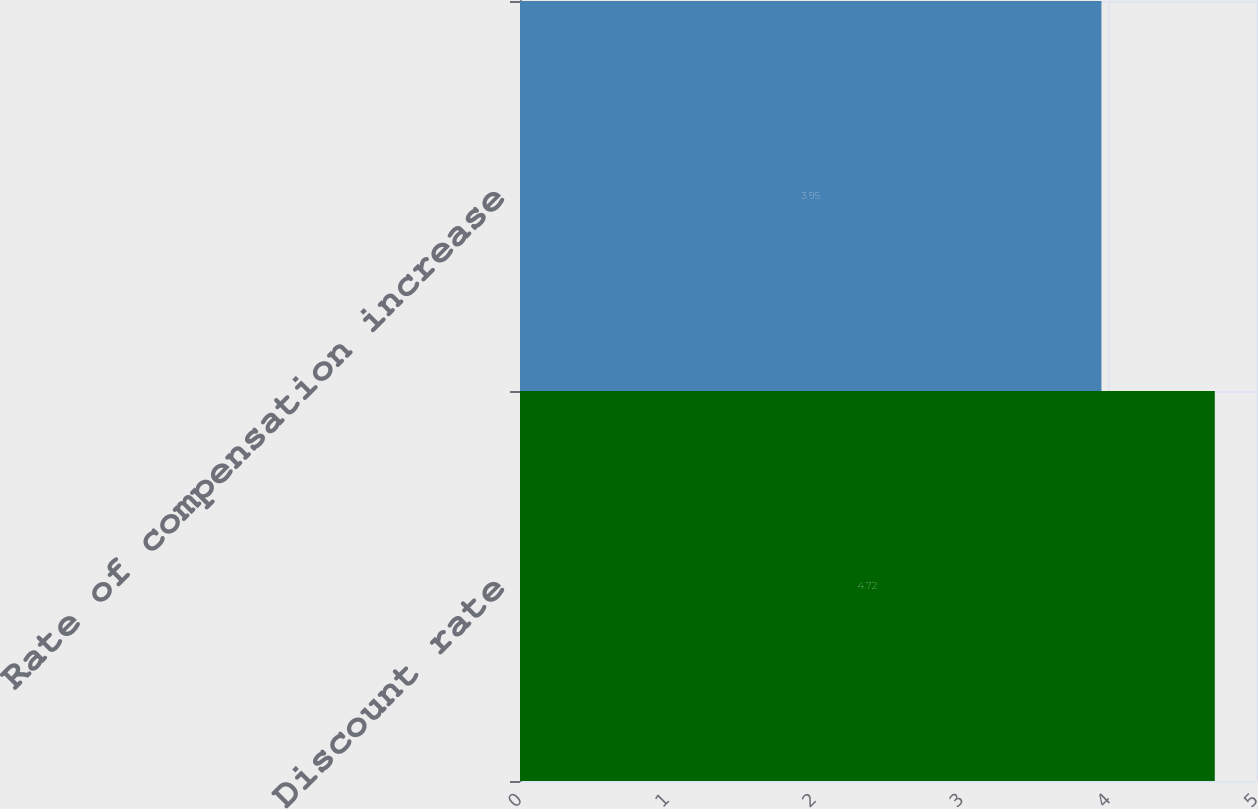Convert chart to OTSL. <chart><loc_0><loc_0><loc_500><loc_500><bar_chart><fcel>Discount rate<fcel>Rate of compensation increase<nl><fcel>4.72<fcel>3.95<nl></chart> 